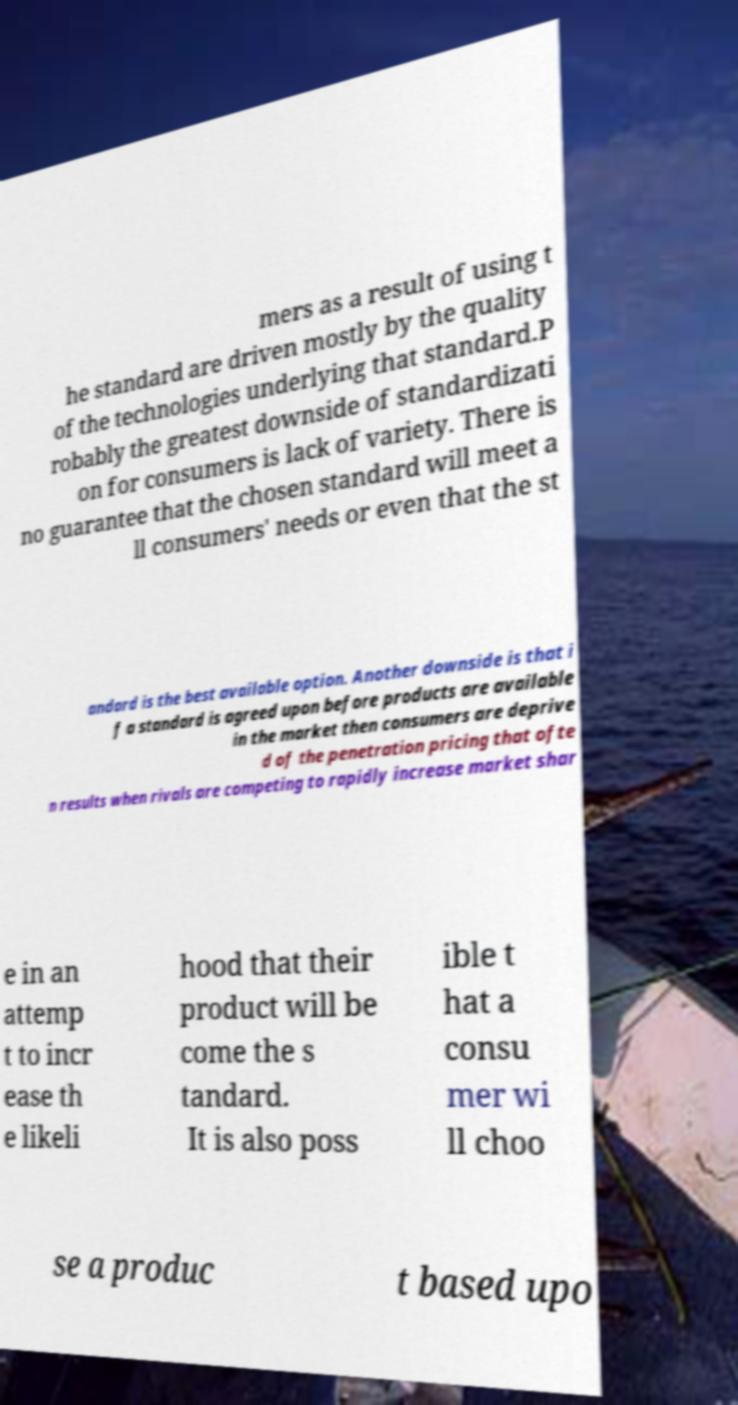Can you accurately transcribe the text from the provided image for me? mers as a result of using t he standard are driven mostly by the quality of the technologies underlying that standard.P robably the greatest downside of standardizati on for consumers is lack of variety. There is no guarantee that the chosen standard will meet a ll consumers' needs or even that the st andard is the best available option. Another downside is that i f a standard is agreed upon before products are available in the market then consumers are deprive d of the penetration pricing that ofte n results when rivals are competing to rapidly increase market shar e in an attemp t to incr ease th e likeli hood that their product will be come the s tandard. It is also poss ible t hat a consu mer wi ll choo se a produc t based upo 